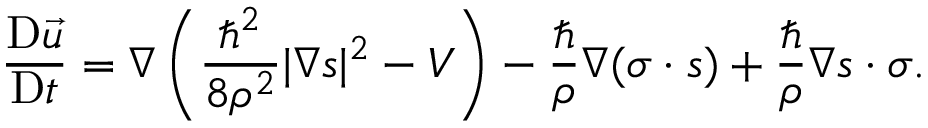Convert formula to latex. <formula><loc_0><loc_0><loc_500><loc_500>\frac { D \vec { u } } { D t } = \nabla \left ( \frac { { } ^ { 2 } } { 8 \rho ^ { 2 } } | \nabla s | ^ { 2 } - V \right ) - \frac { } { \rho } \nabla ( \sigma \cdot s ) + \frac { } { \rho } \nabla s \cdot \sigma .</formula> 